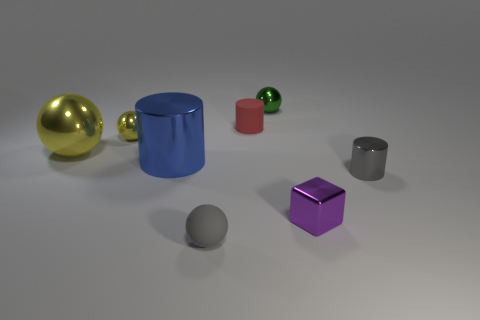What number of other objects are the same shape as the small red rubber thing?
Offer a terse response. 2. There is a tiny cylinder that is behind the small yellow metallic object; is its color the same as the large metal thing behind the blue object?
Give a very brief answer. No. What number of big objects are either shiny blocks or yellow metal balls?
Provide a succinct answer. 1. What size is the blue object that is the same shape as the tiny red object?
Your answer should be compact. Large. Is there any other thing that is the same size as the green metal object?
Provide a succinct answer. Yes. There is a small ball that is in front of the metal cylinder to the left of the small gray metal thing; what is its material?
Ensure brevity in your answer.  Rubber. What number of metallic things are either tiny green things or small red things?
Your response must be concise. 1. What color is the tiny metallic object that is the same shape as the red rubber thing?
Offer a terse response. Gray. How many tiny metallic things are the same color as the small metallic cylinder?
Provide a succinct answer. 0. Are there any small gray shiny things that are to the left of the tiny object that is in front of the tiny purple shiny thing?
Offer a very short reply. No. 